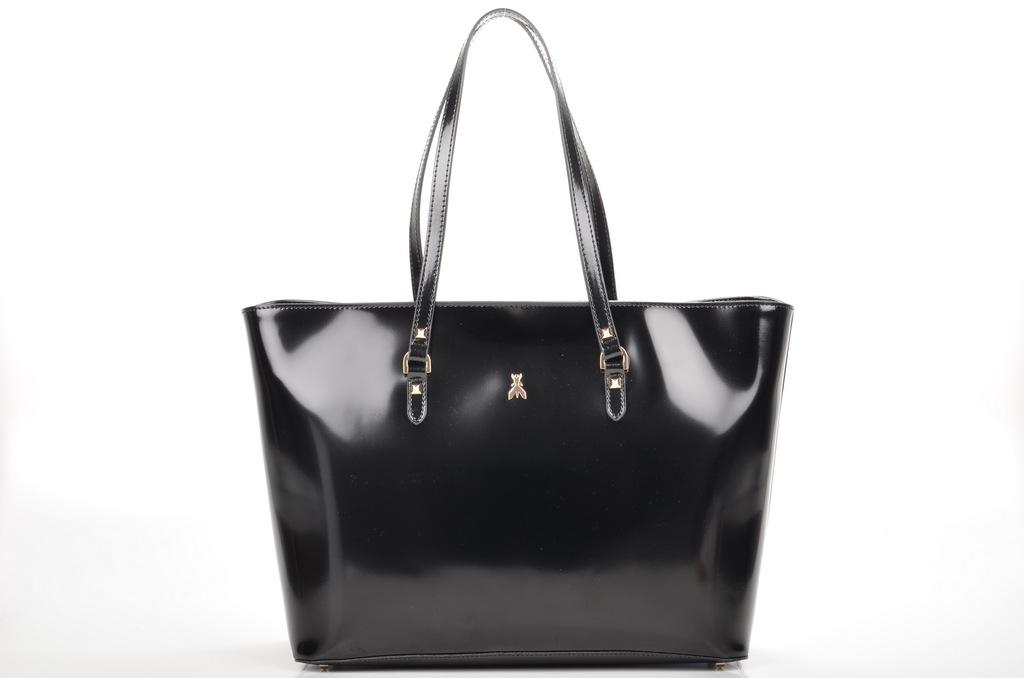What object can be seen in the image? There is a bag in the image. What type of cracker is being eaten by the person on the coast in the image? There is no person, cracker, or coast present in the image; it only features a bag. 